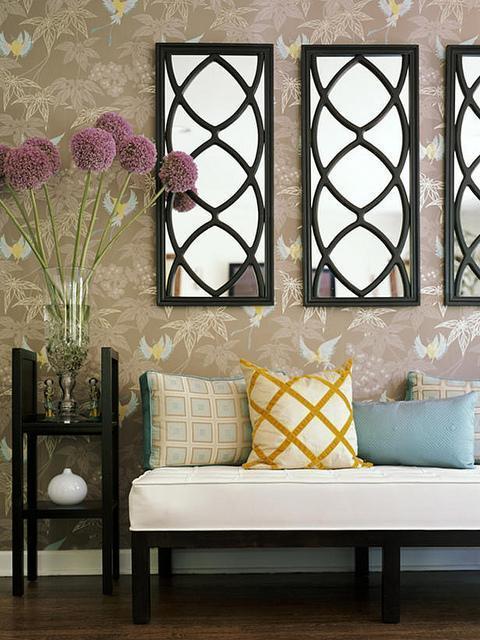How many people are sitting on the couch?
Give a very brief answer. 0. 